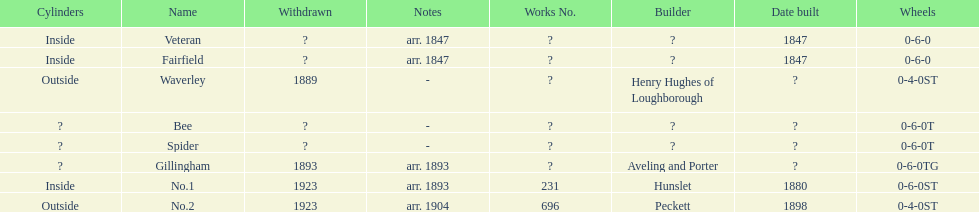What name is listed after spider? Gillingham. Could you parse the entire table? {'header': ['Cylinders', 'Name', 'Withdrawn', 'Notes', 'Works No.', 'Builder', 'Date built', 'Wheels'], 'rows': [['Inside', 'Veteran', '?', 'arr. 1847', '?', '?', '1847', '0-6-0'], ['Inside', 'Fairfield', '?', 'arr. 1847', '?', '?', '1847', '0-6-0'], ['Outside', 'Waverley', '1889', '-', '?', 'Henry Hughes of Loughborough', '?', '0-4-0ST'], ['?', 'Bee', '?', '-', '?', '?', '?', '0-6-0T'], ['?', 'Spider', '?', '-', '?', '?', '?', '0-6-0T'], ['?', 'Gillingham', '1893', 'arr. 1893', '?', 'Aveling and Porter', '?', '0-6-0TG'], ['Inside', 'No.1', '1923', 'arr. 1893', '231', 'Hunslet', '1880', '0-6-0ST'], ['Outside', 'No.2', '1923', 'arr. 1904', '696', 'Peckett', '1898', '0-4-0ST']]} 